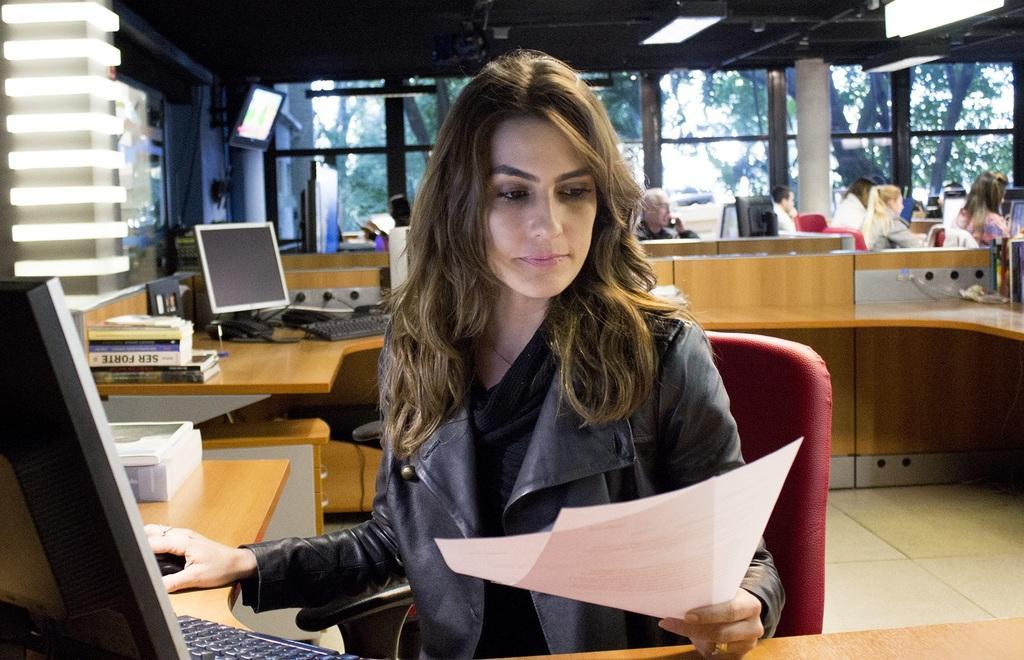Describe this image in one or two sentences. In the picture we can see inside the office view with desk and computer system on it and near it, we can see a woman sitting and holding some papers and looking into it and beside the desk also we can see another desk with computer system and behind it, we can see some people are working and behind them we can see the glass wall and from it we can see some trees and to the ceiling we can see the light. 